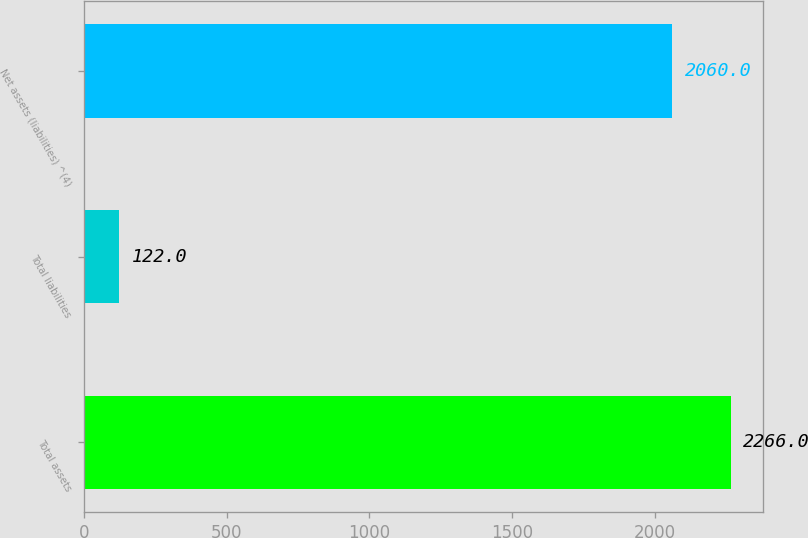Convert chart to OTSL. <chart><loc_0><loc_0><loc_500><loc_500><bar_chart><fcel>Total assets<fcel>Total liabilities<fcel>Net assets (liabilities) ^(4)<nl><fcel>2266<fcel>122<fcel>2060<nl></chart> 